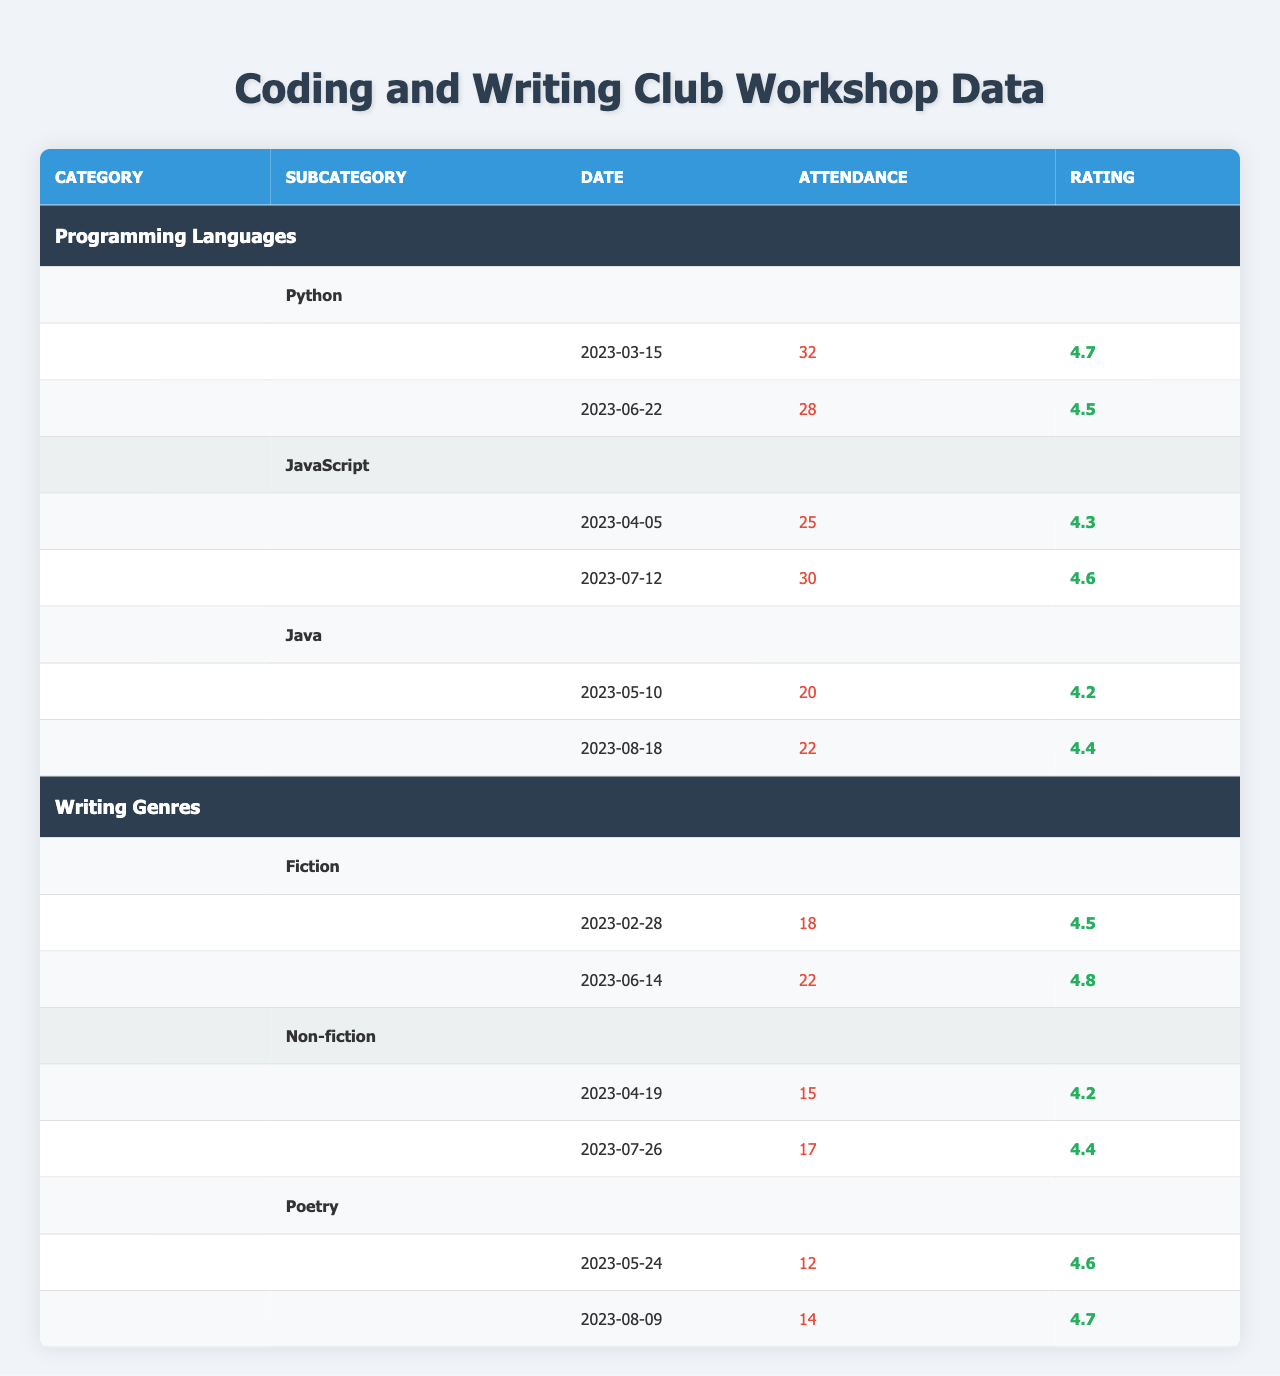What is the highest attendance recorded for Python workshops? The data shows two workshops for Python attendance figures: 32 and 28. The highest attendance is the larger value, which is 32.
Answer: 32 Which writing genre had the highest rating in its workshops? The ratings for Fiction are 4.5 and 4.8, for Non-fiction they are 4.2 and 4.4, and for Poetry they are 4.6 and 4.7. 4.8 from Fiction is the highest rating.
Answer: Fiction What is the total attendance for Java workshops? The attendance for Java workshops is 20 and 22. Adding these gives 20 + 22 = 42.
Answer: 42 Did the JavaScript workshops receive an average rating above 4.5? The JavaScript workshop ratings are 4.3 and 4.6. The average is (4.3 + 4.6) / 2 = 4.45, which is below 4.5.
Answer: No What is the average rating of all workshops for the writing genre Poetry? Poetry has two workshops with ratings of 4.6 and 4.7. Adding these gives 4.6 + 4.7 = 9.3. Dividing by the number of workshops (2) results in 9.3 / 2 = 4.65.
Answer: 4.65 Which programming language had the most workshops? Python has 2 workshops, JavaScript has 2, and Java has 2. All have the same number of workshops, which is 2.
Answer: None, they are all equal What is the difference in attendance between the highest and lowest attended Writing workshops? The highest attendance for Writing is 22 (Fiction), and the lowest is 15 (Non-fiction). The difference is 22 - 15 = 7.
Answer: 7 Which month had the most workshops across all categories? In examining the workshop dates, March has one, April has two, May has two, June has two, July has two, August has two. The months with the most workshops are April, May, June, July, and August, all having two workshops.
Answer: None, they are all equal What is the total attendance for all workshops conducted in June? In June, the workshops are for Python (28 attendees) and Writing Fiction (22 attendees), making total attendance 28 + 22 = 50.
Answer: 50 Was the rating of the last Java workshop higher than the first Python workshop? Java's last workshop had a rating of 4.4, and the first Python workshop's rating was 4.7. Since 4.4 is less than 4.7, the statement is false.
Answer: No 